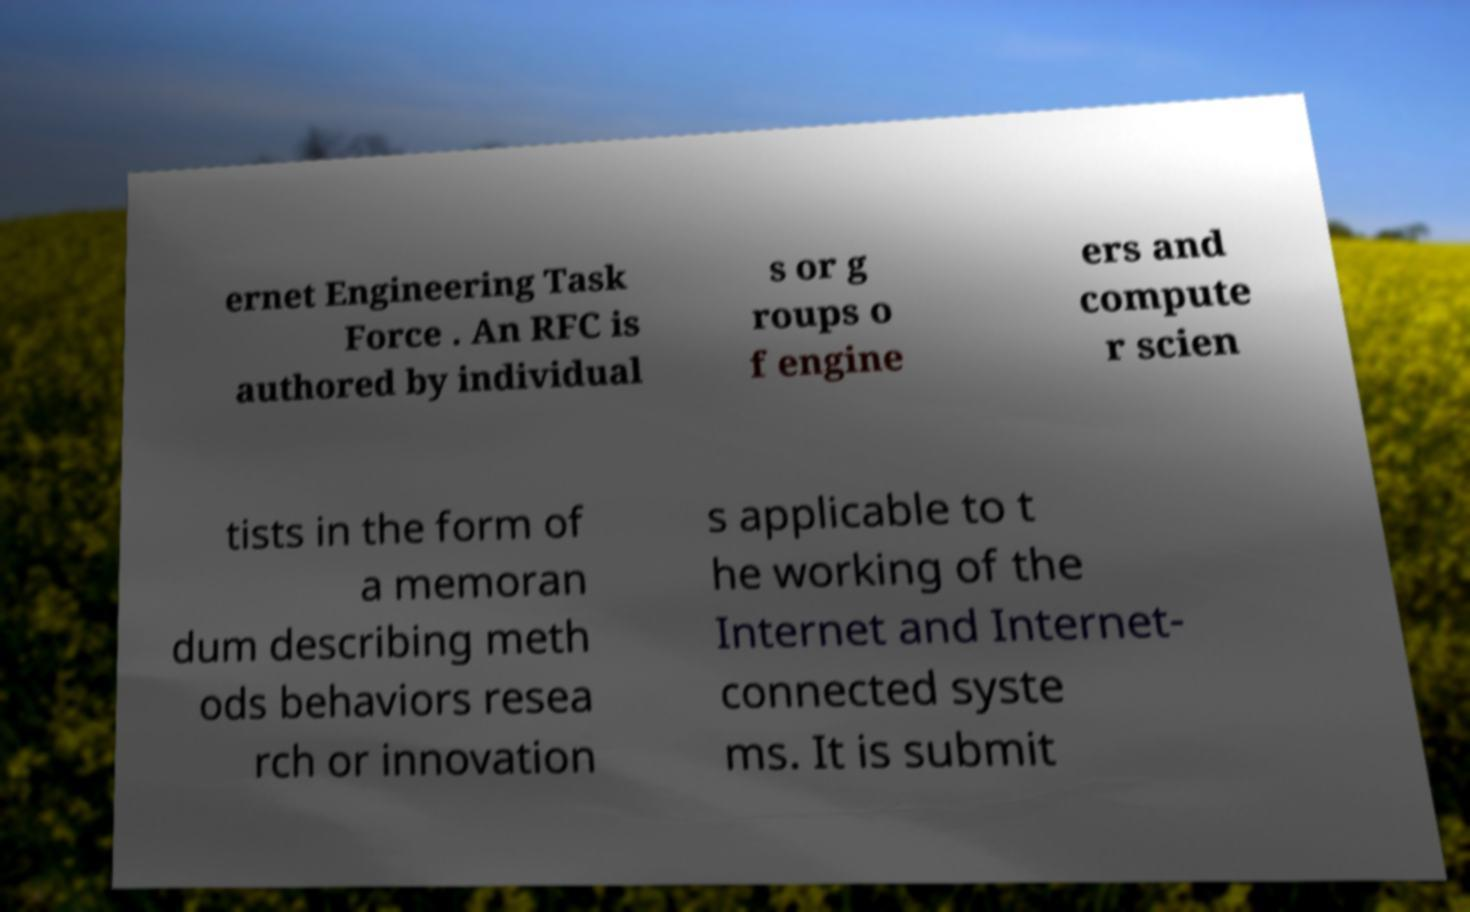Could you extract and type out the text from this image? ernet Engineering Task Force . An RFC is authored by individual s or g roups o f engine ers and compute r scien tists in the form of a memoran dum describing meth ods behaviors resea rch or innovation s applicable to t he working of the Internet and Internet- connected syste ms. It is submit 